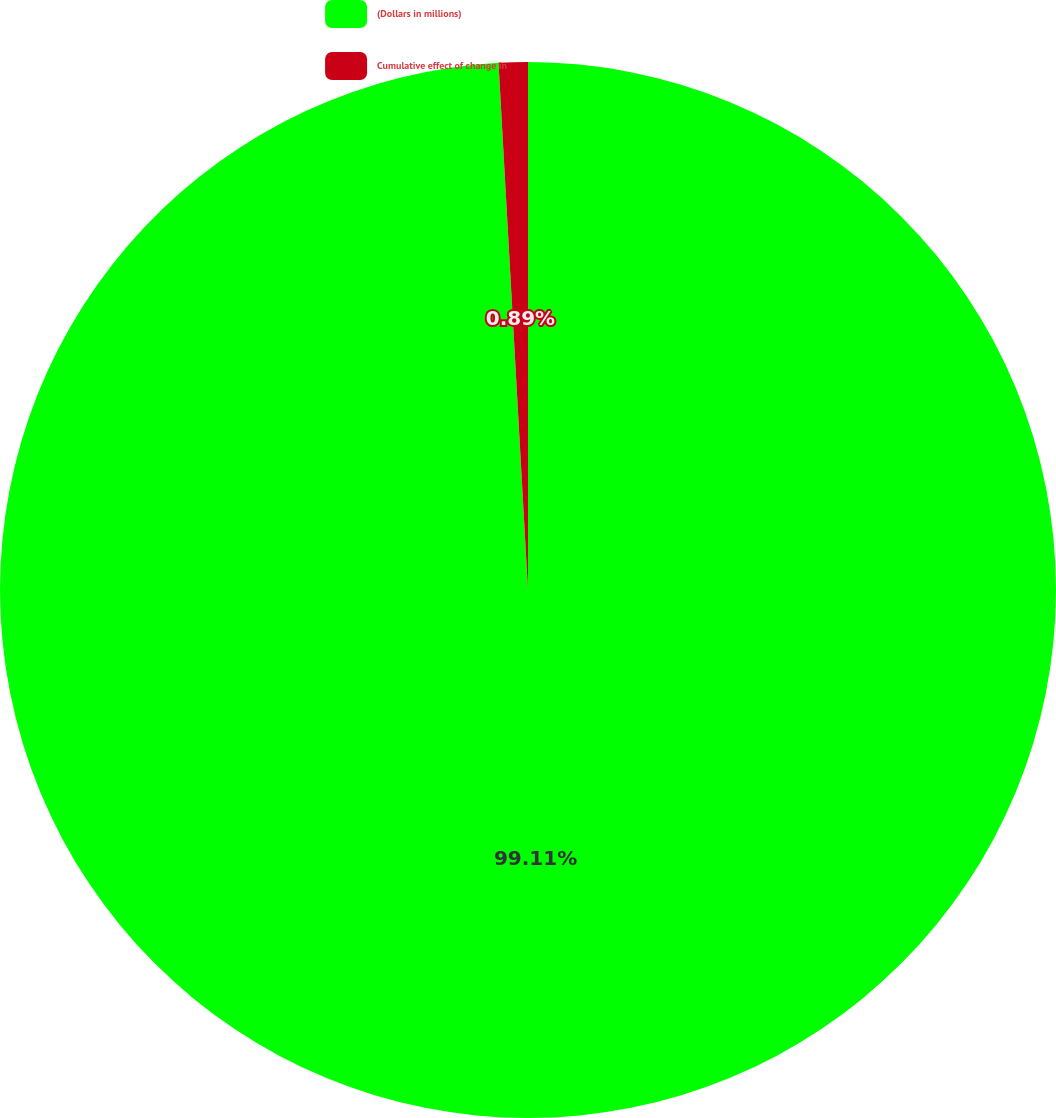Convert chart to OTSL. <chart><loc_0><loc_0><loc_500><loc_500><pie_chart><fcel>(Dollars in millions)<fcel>Cumulative effect of change in<nl><fcel>99.11%<fcel>0.89%<nl></chart> 